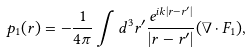Convert formula to latex. <formula><loc_0><loc_0><loc_500><loc_500>p _ { 1 } ( r ) = - \frac { 1 } { 4 \pi } \int d ^ { 3 } r ^ { \prime } \frac { e ^ { i k | r - r ^ { \prime } | } } { | r - r ^ { \prime } | } ( \nabla \cdot F _ { 1 } ) ,</formula> 